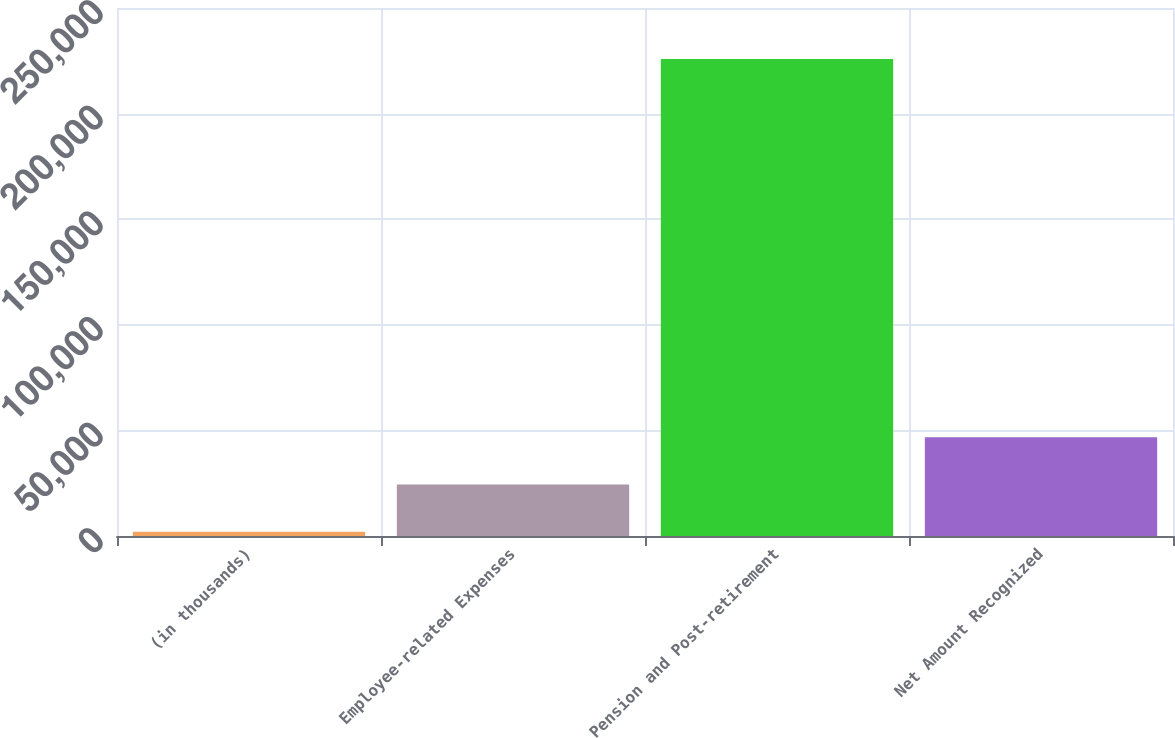<chart> <loc_0><loc_0><loc_500><loc_500><bar_chart><fcel>(in thousands)<fcel>Employee-related Expenses<fcel>Pension and Post-retirement<fcel>Net Amount Recognized<nl><fcel>2018<fcel>24398.7<fcel>225825<fcel>46779.4<nl></chart> 